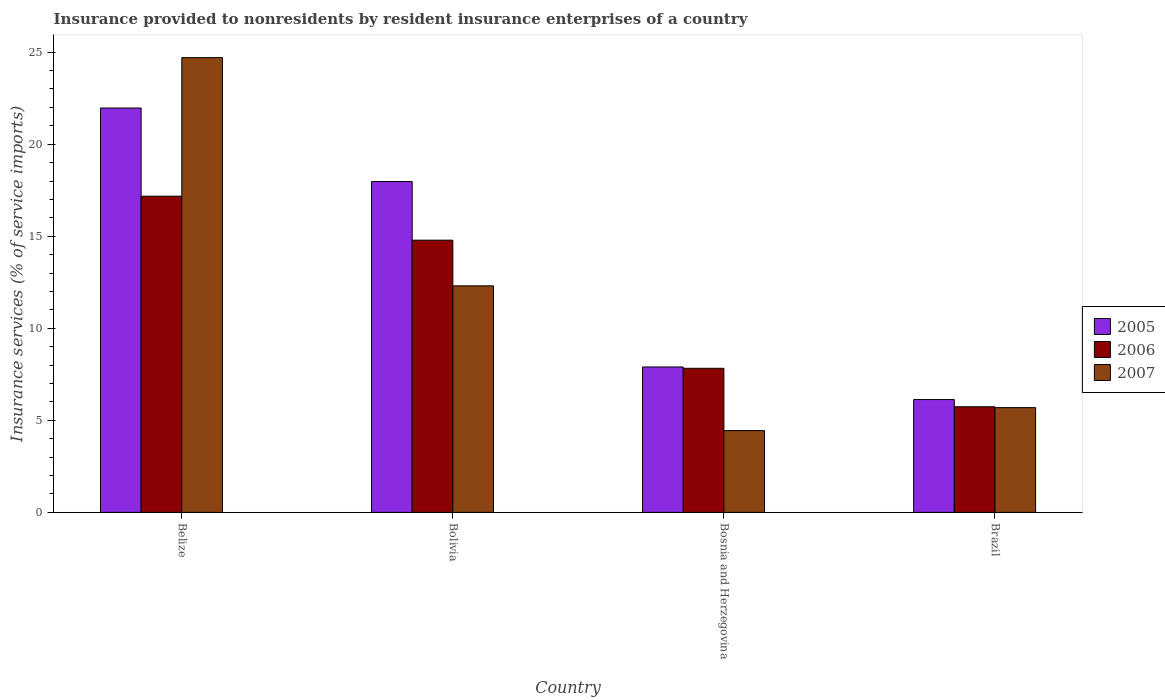How many different coloured bars are there?
Ensure brevity in your answer.  3. Are the number of bars per tick equal to the number of legend labels?
Your answer should be compact. Yes. How many bars are there on the 4th tick from the right?
Keep it short and to the point. 3. What is the label of the 1st group of bars from the left?
Offer a very short reply. Belize. What is the insurance provided to nonresidents in 2006 in Bolivia?
Make the answer very short. 14.79. Across all countries, what is the maximum insurance provided to nonresidents in 2005?
Your answer should be very brief. 21.96. Across all countries, what is the minimum insurance provided to nonresidents in 2006?
Ensure brevity in your answer.  5.74. In which country was the insurance provided to nonresidents in 2005 maximum?
Ensure brevity in your answer.  Belize. In which country was the insurance provided to nonresidents in 2007 minimum?
Make the answer very short. Bosnia and Herzegovina. What is the total insurance provided to nonresidents in 2007 in the graph?
Offer a very short reply. 47.14. What is the difference between the insurance provided to nonresidents in 2006 in Bosnia and Herzegovina and that in Brazil?
Provide a succinct answer. 2.09. What is the difference between the insurance provided to nonresidents in 2006 in Bosnia and Herzegovina and the insurance provided to nonresidents in 2005 in Brazil?
Provide a short and direct response. 1.7. What is the average insurance provided to nonresidents in 2006 per country?
Offer a very short reply. 11.38. What is the difference between the insurance provided to nonresidents of/in 2006 and insurance provided to nonresidents of/in 2007 in Bosnia and Herzegovina?
Provide a short and direct response. 3.38. What is the ratio of the insurance provided to nonresidents in 2005 in Bolivia to that in Bosnia and Herzegovina?
Provide a succinct answer. 2.28. Is the difference between the insurance provided to nonresidents in 2006 in Bosnia and Herzegovina and Brazil greater than the difference between the insurance provided to nonresidents in 2007 in Bosnia and Herzegovina and Brazil?
Offer a terse response. Yes. What is the difference between the highest and the second highest insurance provided to nonresidents in 2006?
Give a very brief answer. 2.39. What is the difference between the highest and the lowest insurance provided to nonresidents in 2006?
Offer a very short reply. 11.44. What does the 2nd bar from the left in Bosnia and Herzegovina represents?
Keep it short and to the point. 2006. What does the 3rd bar from the right in Brazil represents?
Keep it short and to the point. 2005. Is it the case that in every country, the sum of the insurance provided to nonresidents in 2007 and insurance provided to nonresidents in 2006 is greater than the insurance provided to nonresidents in 2005?
Your response must be concise. Yes. How many countries are there in the graph?
Your response must be concise. 4. What is the difference between two consecutive major ticks on the Y-axis?
Your answer should be compact. 5. What is the title of the graph?
Keep it short and to the point. Insurance provided to nonresidents by resident insurance enterprises of a country. Does "2002" appear as one of the legend labels in the graph?
Your response must be concise. No. What is the label or title of the Y-axis?
Offer a very short reply. Insurance services (% of service imports). What is the Insurance services (% of service imports) in 2005 in Belize?
Provide a short and direct response. 21.96. What is the Insurance services (% of service imports) in 2006 in Belize?
Your response must be concise. 17.18. What is the Insurance services (% of service imports) of 2007 in Belize?
Provide a succinct answer. 24.7. What is the Insurance services (% of service imports) in 2005 in Bolivia?
Your answer should be compact. 17.97. What is the Insurance services (% of service imports) in 2006 in Bolivia?
Make the answer very short. 14.79. What is the Insurance services (% of service imports) in 2007 in Bolivia?
Provide a succinct answer. 12.31. What is the Insurance services (% of service imports) in 2005 in Bosnia and Herzegovina?
Offer a terse response. 7.9. What is the Insurance services (% of service imports) in 2006 in Bosnia and Herzegovina?
Your answer should be compact. 7.83. What is the Insurance services (% of service imports) of 2007 in Bosnia and Herzegovina?
Offer a very short reply. 4.44. What is the Insurance services (% of service imports) in 2005 in Brazil?
Provide a succinct answer. 6.13. What is the Insurance services (% of service imports) of 2006 in Brazil?
Ensure brevity in your answer.  5.74. What is the Insurance services (% of service imports) in 2007 in Brazil?
Offer a very short reply. 5.69. Across all countries, what is the maximum Insurance services (% of service imports) of 2005?
Provide a succinct answer. 21.96. Across all countries, what is the maximum Insurance services (% of service imports) of 2006?
Keep it short and to the point. 17.18. Across all countries, what is the maximum Insurance services (% of service imports) of 2007?
Your answer should be very brief. 24.7. Across all countries, what is the minimum Insurance services (% of service imports) in 2005?
Your answer should be very brief. 6.13. Across all countries, what is the minimum Insurance services (% of service imports) of 2006?
Offer a very short reply. 5.74. Across all countries, what is the minimum Insurance services (% of service imports) in 2007?
Offer a very short reply. 4.44. What is the total Insurance services (% of service imports) in 2005 in the graph?
Make the answer very short. 53.97. What is the total Insurance services (% of service imports) of 2006 in the graph?
Provide a succinct answer. 45.53. What is the total Insurance services (% of service imports) in 2007 in the graph?
Provide a succinct answer. 47.14. What is the difference between the Insurance services (% of service imports) of 2005 in Belize and that in Bolivia?
Your response must be concise. 3.99. What is the difference between the Insurance services (% of service imports) in 2006 in Belize and that in Bolivia?
Your response must be concise. 2.39. What is the difference between the Insurance services (% of service imports) in 2007 in Belize and that in Bolivia?
Offer a terse response. 12.4. What is the difference between the Insurance services (% of service imports) in 2005 in Belize and that in Bosnia and Herzegovina?
Give a very brief answer. 14.07. What is the difference between the Insurance services (% of service imports) of 2006 in Belize and that in Bosnia and Herzegovina?
Your response must be concise. 9.35. What is the difference between the Insurance services (% of service imports) of 2007 in Belize and that in Bosnia and Herzegovina?
Offer a very short reply. 20.26. What is the difference between the Insurance services (% of service imports) in 2005 in Belize and that in Brazil?
Keep it short and to the point. 15.84. What is the difference between the Insurance services (% of service imports) in 2006 in Belize and that in Brazil?
Provide a short and direct response. 11.44. What is the difference between the Insurance services (% of service imports) in 2007 in Belize and that in Brazil?
Keep it short and to the point. 19.01. What is the difference between the Insurance services (% of service imports) in 2005 in Bolivia and that in Bosnia and Herzegovina?
Your answer should be compact. 10.07. What is the difference between the Insurance services (% of service imports) of 2006 in Bolivia and that in Bosnia and Herzegovina?
Offer a very short reply. 6.96. What is the difference between the Insurance services (% of service imports) of 2007 in Bolivia and that in Bosnia and Herzegovina?
Give a very brief answer. 7.86. What is the difference between the Insurance services (% of service imports) in 2005 in Bolivia and that in Brazil?
Keep it short and to the point. 11.84. What is the difference between the Insurance services (% of service imports) of 2006 in Bolivia and that in Brazil?
Make the answer very short. 9.05. What is the difference between the Insurance services (% of service imports) in 2007 in Bolivia and that in Brazil?
Your answer should be compact. 6.62. What is the difference between the Insurance services (% of service imports) of 2005 in Bosnia and Herzegovina and that in Brazil?
Keep it short and to the point. 1.77. What is the difference between the Insurance services (% of service imports) in 2006 in Bosnia and Herzegovina and that in Brazil?
Your answer should be compact. 2.09. What is the difference between the Insurance services (% of service imports) of 2007 in Bosnia and Herzegovina and that in Brazil?
Offer a terse response. -1.25. What is the difference between the Insurance services (% of service imports) of 2005 in Belize and the Insurance services (% of service imports) of 2006 in Bolivia?
Your answer should be very brief. 7.18. What is the difference between the Insurance services (% of service imports) in 2005 in Belize and the Insurance services (% of service imports) in 2007 in Bolivia?
Offer a terse response. 9.66. What is the difference between the Insurance services (% of service imports) in 2006 in Belize and the Insurance services (% of service imports) in 2007 in Bolivia?
Give a very brief answer. 4.87. What is the difference between the Insurance services (% of service imports) of 2005 in Belize and the Insurance services (% of service imports) of 2006 in Bosnia and Herzegovina?
Ensure brevity in your answer.  14.14. What is the difference between the Insurance services (% of service imports) of 2005 in Belize and the Insurance services (% of service imports) of 2007 in Bosnia and Herzegovina?
Make the answer very short. 17.52. What is the difference between the Insurance services (% of service imports) of 2006 in Belize and the Insurance services (% of service imports) of 2007 in Bosnia and Herzegovina?
Offer a very short reply. 12.73. What is the difference between the Insurance services (% of service imports) in 2005 in Belize and the Insurance services (% of service imports) in 2006 in Brazil?
Offer a terse response. 16.23. What is the difference between the Insurance services (% of service imports) in 2005 in Belize and the Insurance services (% of service imports) in 2007 in Brazil?
Provide a succinct answer. 16.27. What is the difference between the Insurance services (% of service imports) in 2006 in Belize and the Insurance services (% of service imports) in 2007 in Brazil?
Offer a very short reply. 11.49. What is the difference between the Insurance services (% of service imports) in 2005 in Bolivia and the Insurance services (% of service imports) in 2006 in Bosnia and Herzegovina?
Give a very brief answer. 10.15. What is the difference between the Insurance services (% of service imports) of 2005 in Bolivia and the Insurance services (% of service imports) of 2007 in Bosnia and Herzegovina?
Your answer should be compact. 13.53. What is the difference between the Insurance services (% of service imports) in 2006 in Bolivia and the Insurance services (% of service imports) in 2007 in Bosnia and Herzegovina?
Provide a short and direct response. 10.34. What is the difference between the Insurance services (% of service imports) of 2005 in Bolivia and the Insurance services (% of service imports) of 2006 in Brazil?
Provide a short and direct response. 12.23. What is the difference between the Insurance services (% of service imports) of 2005 in Bolivia and the Insurance services (% of service imports) of 2007 in Brazil?
Keep it short and to the point. 12.28. What is the difference between the Insurance services (% of service imports) of 2006 in Bolivia and the Insurance services (% of service imports) of 2007 in Brazil?
Give a very brief answer. 9.1. What is the difference between the Insurance services (% of service imports) in 2005 in Bosnia and Herzegovina and the Insurance services (% of service imports) in 2006 in Brazil?
Make the answer very short. 2.16. What is the difference between the Insurance services (% of service imports) in 2005 in Bosnia and Herzegovina and the Insurance services (% of service imports) in 2007 in Brazil?
Ensure brevity in your answer.  2.21. What is the difference between the Insurance services (% of service imports) of 2006 in Bosnia and Herzegovina and the Insurance services (% of service imports) of 2007 in Brazil?
Offer a terse response. 2.14. What is the average Insurance services (% of service imports) in 2005 per country?
Provide a succinct answer. 13.49. What is the average Insurance services (% of service imports) in 2006 per country?
Your answer should be very brief. 11.38. What is the average Insurance services (% of service imports) in 2007 per country?
Provide a short and direct response. 11.79. What is the difference between the Insurance services (% of service imports) of 2005 and Insurance services (% of service imports) of 2006 in Belize?
Provide a succinct answer. 4.79. What is the difference between the Insurance services (% of service imports) of 2005 and Insurance services (% of service imports) of 2007 in Belize?
Your response must be concise. -2.74. What is the difference between the Insurance services (% of service imports) of 2006 and Insurance services (% of service imports) of 2007 in Belize?
Make the answer very short. -7.53. What is the difference between the Insurance services (% of service imports) in 2005 and Insurance services (% of service imports) in 2006 in Bolivia?
Provide a succinct answer. 3.19. What is the difference between the Insurance services (% of service imports) of 2005 and Insurance services (% of service imports) of 2007 in Bolivia?
Ensure brevity in your answer.  5.67. What is the difference between the Insurance services (% of service imports) in 2006 and Insurance services (% of service imports) in 2007 in Bolivia?
Keep it short and to the point. 2.48. What is the difference between the Insurance services (% of service imports) of 2005 and Insurance services (% of service imports) of 2006 in Bosnia and Herzegovina?
Keep it short and to the point. 0.07. What is the difference between the Insurance services (% of service imports) of 2005 and Insurance services (% of service imports) of 2007 in Bosnia and Herzegovina?
Your response must be concise. 3.46. What is the difference between the Insurance services (% of service imports) of 2006 and Insurance services (% of service imports) of 2007 in Bosnia and Herzegovina?
Your answer should be compact. 3.38. What is the difference between the Insurance services (% of service imports) in 2005 and Insurance services (% of service imports) in 2006 in Brazil?
Your answer should be compact. 0.39. What is the difference between the Insurance services (% of service imports) in 2005 and Insurance services (% of service imports) in 2007 in Brazil?
Provide a short and direct response. 0.44. What is the difference between the Insurance services (% of service imports) in 2006 and Insurance services (% of service imports) in 2007 in Brazil?
Your answer should be compact. 0.05. What is the ratio of the Insurance services (% of service imports) of 2005 in Belize to that in Bolivia?
Keep it short and to the point. 1.22. What is the ratio of the Insurance services (% of service imports) of 2006 in Belize to that in Bolivia?
Give a very brief answer. 1.16. What is the ratio of the Insurance services (% of service imports) in 2007 in Belize to that in Bolivia?
Offer a terse response. 2.01. What is the ratio of the Insurance services (% of service imports) of 2005 in Belize to that in Bosnia and Herzegovina?
Your answer should be very brief. 2.78. What is the ratio of the Insurance services (% of service imports) of 2006 in Belize to that in Bosnia and Herzegovina?
Offer a very short reply. 2.19. What is the ratio of the Insurance services (% of service imports) of 2007 in Belize to that in Bosnia and Herzegovina?
Offer a terse response. 5.56. What is the ratio of the Insurance services (% of service imports) in 2005 in Belize to that in Brazil?
Offer a very short reply. 3.58. What is the ratio of the Insurance services (% of service imports) in 2006 in Belize to that in Brazil?
Provide a short and direct response. 2.99. What is the ratio of the Insurance services (% of service imports) in 2007 in Belize to that in Brazil?
Offer a terse response. 4.34. What is the ratio of the Insurance services (% of service imports) of 2005 in Bolivia to that in Bosnia and Herzegovina?
Ensure brevity in your answer.  2.28. What is the ratio of the Insurance services (% of service imports) of 2006 in Bolivia to that in Bosnia and Herzegovina?
Give a very brief answer. 1.89. What is the ratio of the Insurance services (% of service imports) in 2007 in Bolivia to that in Bosnia and Herzegovina?
Offer a very short reply. 2.77. What is the ratio of the Insurance services (% of service imports) of 2005 in Bolivia to that in Brazil?
Ensure brevity in your answer.  2.93. What is the ratio of the Insurance services (% of service imports) in 2006 in Bolivia to that in Brazil?
Your answer should be very brief. 2.58. What is the ratio of the Insurance services (% of service imports) of 2007 in Bolivia to that in Brazil?
Your answer should be compact. 2.16. What is the ratio of the Insurance services (% of service imports) of 2005 in Bosnia and Herzegovina to that in Brazil?
Provide a succinct answer. 1.29. What is the ratio of the Insurance services (% of service imports) of 2006 in Bosnia and Herzegovina to that in Brazil?
Provide a succinct answer. 1.36. What is the ratio of the Insurance services (% of service imports) in 2007 in Bosnia and Herzegovina to that in Brazil?
Give a very brief answer. 0.78. What is the difference between the highest and the second highest Insurance services (% of service imports) in 2005?
Your answer should be very brief. 3.99. What is the difference between the highest and the second highest Insurance services (% of service imports) of 2006?
Keep it short and to the point. 2.39. What is the difference between the highest and the second highest Insurance services (% of service imports) in 2007?
Your response must be concise. 12.4. What is the difference between the highest and the lowest Insurance services (% of service imports) in 2005?
Make the answer very short. 15.84. What is the difference between the highest and the lowest Insurance services (% of service imports) of 2006?
Offer a terse response. 11.44. What is the difference between the highest and the lowest Insurance services (% of service imports) in 2007?
Your answer should be very brief. 20.26. 